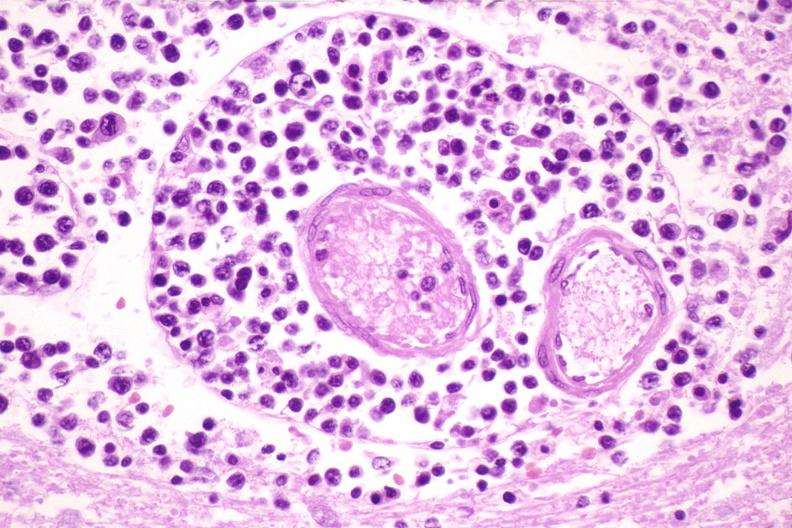where is this?
Answer the question using a single word or phrase. Nervous 